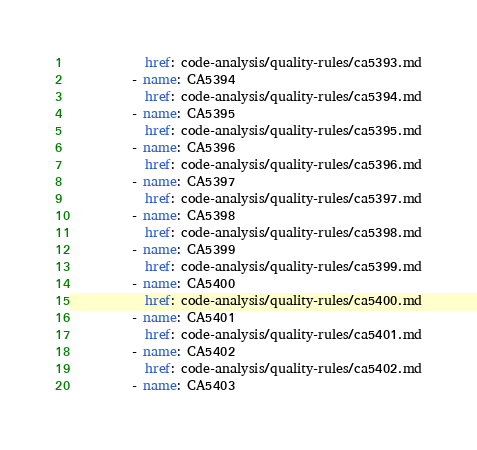<code> <loc_0><loc_0><loc_500><loc_500><_YAML_>            href: code-analysis/quality-rules/ca5393.md
          - name: CA5394
            href: code-analysis/quality-rules/ca5394.md
          - name: CA5395
            href: code-analysis/quality-rules/ca5395.md
          - name: CA5396
            href: code-analysis/quality-rules/ca5396.md
          - name: CA5397
            href: code-analysis/quality-rules/ca5397.md
          - name: CA5398
            href: code-analysis/quality-rules/ca5398.md
          - name: CA5399
            href: code-analysis/quality-rules/ca5399.md
          - name: CA5400
            href: code-analysis/quality-rules/ca5400.md
          - name: CA5401
            href: code-analysis/quality-rules/ca5401.md
          - name: CA5402
            href: code-analysis/quality-rules/ca5402.md
          - name: CA5403</code> 